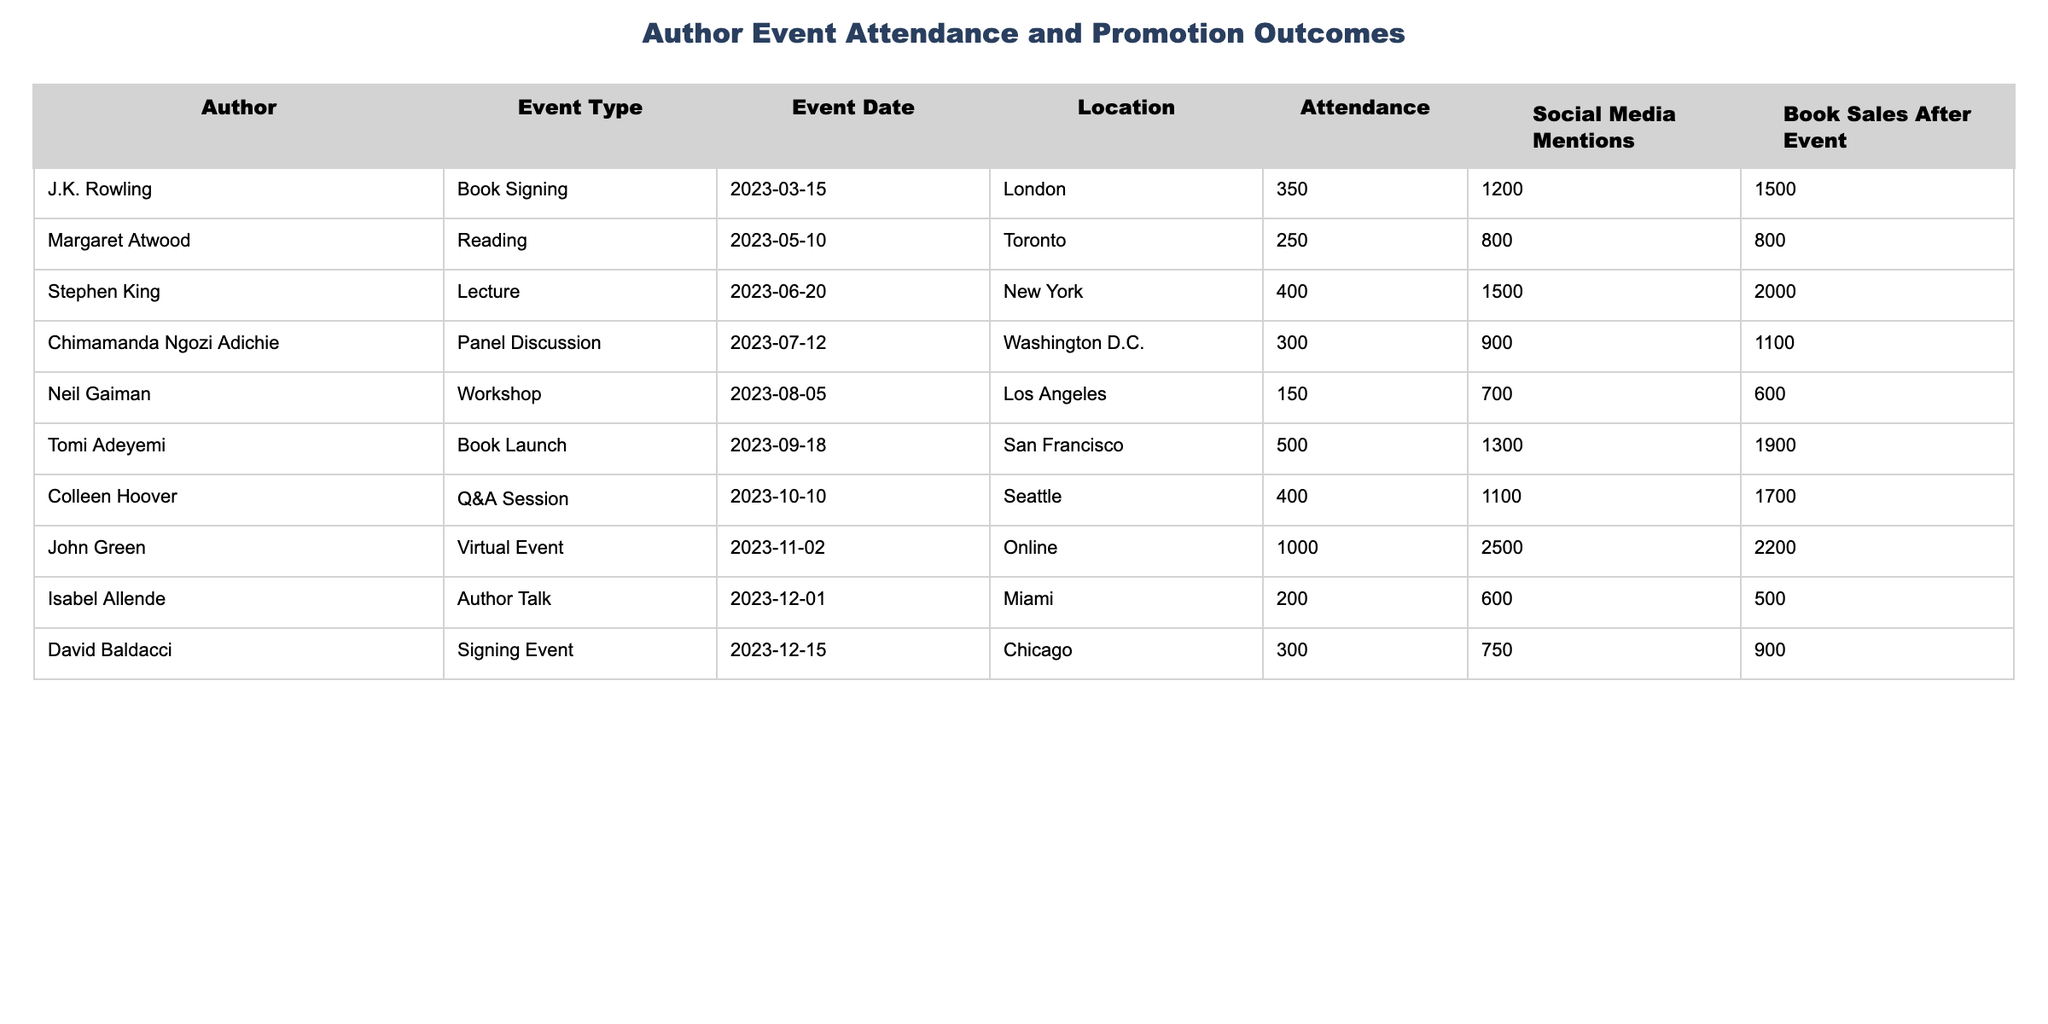What is the attendance for the book signing event by J.K. Rowling? The table lists the attendance for each event, and for J.K. Rowling's book signing on March 15, 2023, the attendance is stated as 350.
Answer: 350 Which author had the highest number of social media mentions? By examining the "Social Media Mentions" column, John Green's virtual event on November 2, 2023, has the highest mentions at 2500.
Answer: 2500 How many more book sales were there after Stephen King's event compared to Neil Gaiman's workshop? The book sales after Stephen King's event were 2000, and after Neil Gaiman's workshop, it was 600. The difference is 2000 - 600 = 1400.
Answer: 1400 What was the average attendance across all events listed? First, sum the attendance values: 350 + 250 + 400 + 300 + 150 + 500 + 400 + 1000 + 200 + 300 = 3850. There are 9 events, so the average is 3850/9 = 427.78.
Answer: 427.78 Did Tomi Adeyemi's book launch have more book sales than Colleen Hoover's Q&A session? Tomi Adeyemi's book launch had 1900 book sales, while Colleen Hoover's Q&A session had 1700. Since 1900 is greater than 1700, the answer is yes.
Answer: Yes What percentage of the total social media mentions were attributed to John Green's virtual event? First, total the social media mentions: 1200 + 800 + 1500 + 900 + 700 + 1300 + 1100 + 2500 + 600 + 750 = 10350. John Green's mentions were 2500, so the percentage is (2500 / 10350) * 100 ≈ 24.15%.
Answer: 24.15% Which event type had the lowest attendance? The lowest attendance is noted for Neil Gaiman's workshop at 150. This is compared against all other attendance figures in the table to determine it is the lowest.
Answer: 150 What were the total book sales for events held in Toronto and Los Angeles? Book sales for the Toronto event (Margaret Atwood, Reading) were 800, and for the Los Angeles workshop (Neil Gaiman) were 600. Adding these gives 800 + 600 = 1400 total book sales.
Answer: 1400 How many events had an attendance greater than 300? By going through each attendance figure, J.K. Rowling (350), Stephen King (400), Chimamanda Ngozi Adichie (300), Tomi Adeyemi (500), Colleen Hoover (400), and John Green (1000) had an attendance greater than 300, totaling 6 events.
Answer: 6 